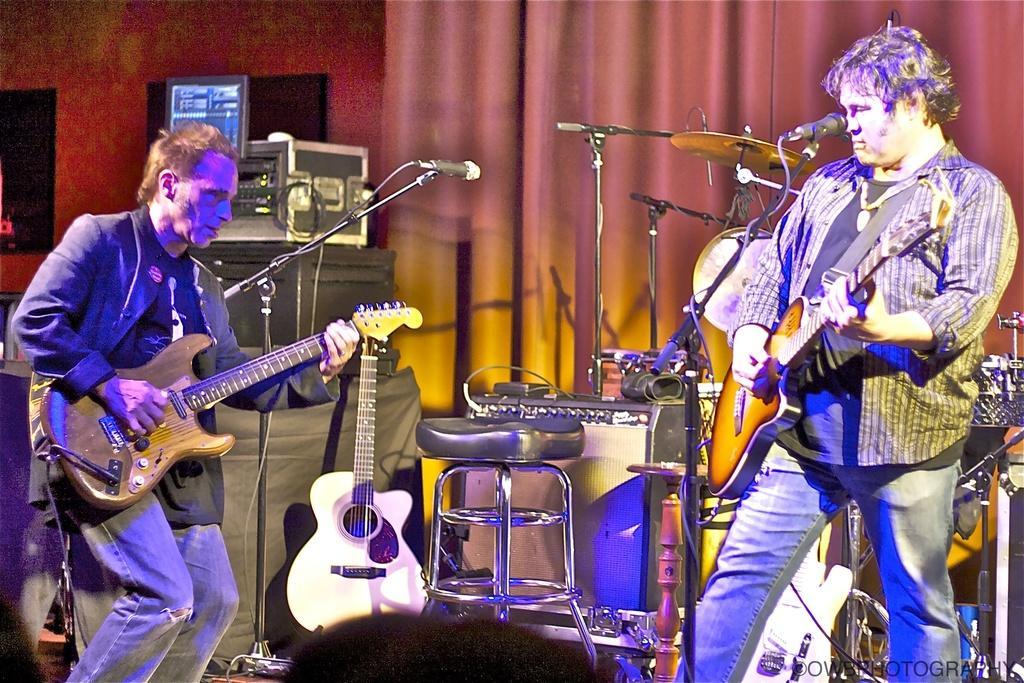Could you give a brief overview of what you see in this image? In this image there is a man standing and playing a guitar , another person standing and playing a guitar and at the back ground there are guitar ,briefcase ,curtain , cymbals , drums, chair , mike stand. 